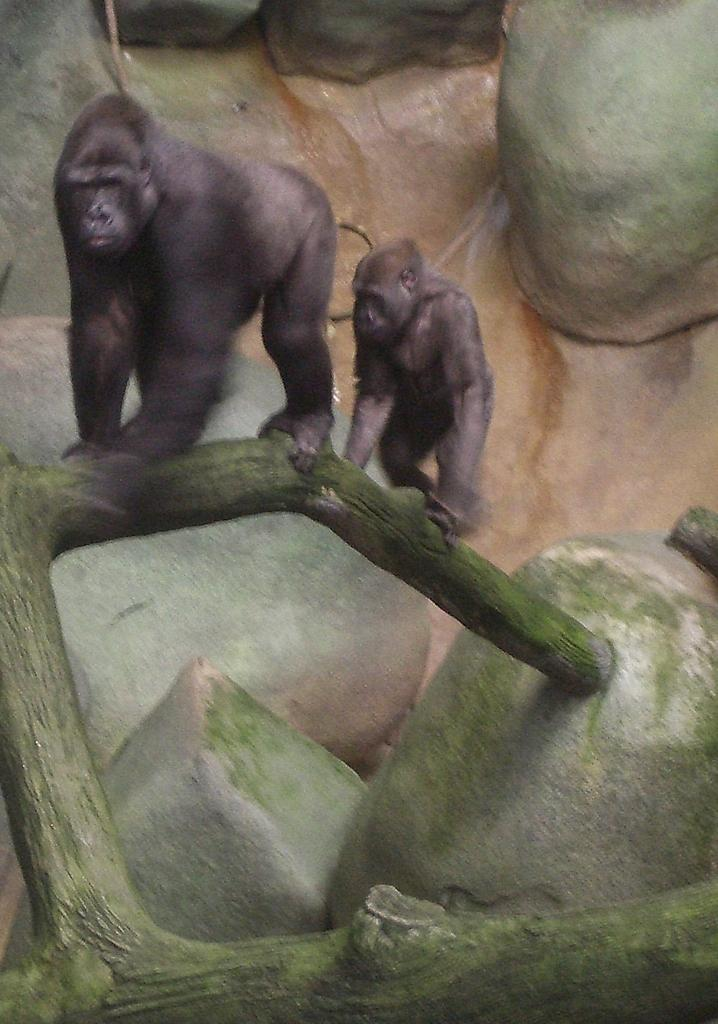How many animals can be seen in the image? There are two animals in the image. What is the color of the animals? The animals are black in color. Where are the animals located in the image? The animals are on a tree branch. What can be seen in the background of the image? There are huge rocks in the background of the image. What type of advertisement can be seen on the tree branch in the image? There is no advertisement present in the image; it features two black animals on a tree branch. How many snails are visible on the tree branch in the image? There are no snails visible on the tree branch in the image; it features two black animals. 